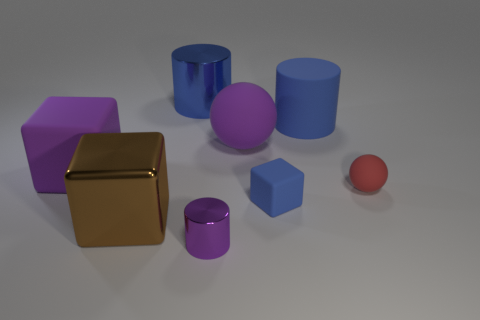How many shiny objects have the same color as the large shiny cube?
Offer a terse response. 0. Are there fewer purple cylinders behind the big shiny cylinder than metal cylinders in front of the tiny blue matte block?
Keep it short and to the point. Yes. There is a small purple metallic thing; how many cylinders are right of it?
Ensure brevity in your answer.  1. Is there a small blue block made of the same material as the red ball?
Offer a terse response. Yes. Are there more blue things that are behind the tiny purple metallic cylinder than purple things that are behind the big brown thing?
Ensure brevity in your answer.  Yes. How big is the purple matte ball?
Provide a short and direct response. Large. What shape is the blue matte object in front of the tiny red thing?
Offer a very short reply. Cube. Is the large brown thing the same shape as the tiny blue matte object?
Offer a terse response. Yes. Are there an equal number of tiny cylinders on the left side of the brown cube and gray cylinders?
Your answer should be compact. Yes. What shape is the small red object?
Offer a terse response. Sphere. 